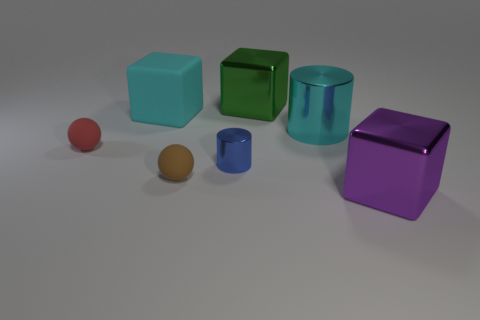There is a metallic object that is the same color as the big rubber cube; what shape is it?
Make the answer very short. Cylinder. What number of blue metallic cylinders are the same size as the green block?
Provide a succinct answer. 0. Does the ball that is behind the tiny shiny cylinder have the same material as the large cyan cube?
Ensure brevity in your answer.  Yes. Are any gray cylinders visible?
Keep it short and to the point. No. The sphere that is the same material as the brown thing is what size?
Your answer should be compact. Small. Are there any small things of the same color as the big metal cylinder?
Offer a terse response. No. Is the color of the metallic thing that is on the right side of the cyan shiny thing the same as the tiny matte object that is in front of the small red rubber object?
Offer a terse response. No. There is a metal thing that is the same color as the large rubber cube; what is its size?
Your response must be concise. Large. Are there any big brown objects that have the same material as the large cyan cylinder?
Ensure brevity in your answer.  No. What is the color of the big matte cube?
Your answer should be very brief. Cyan. 